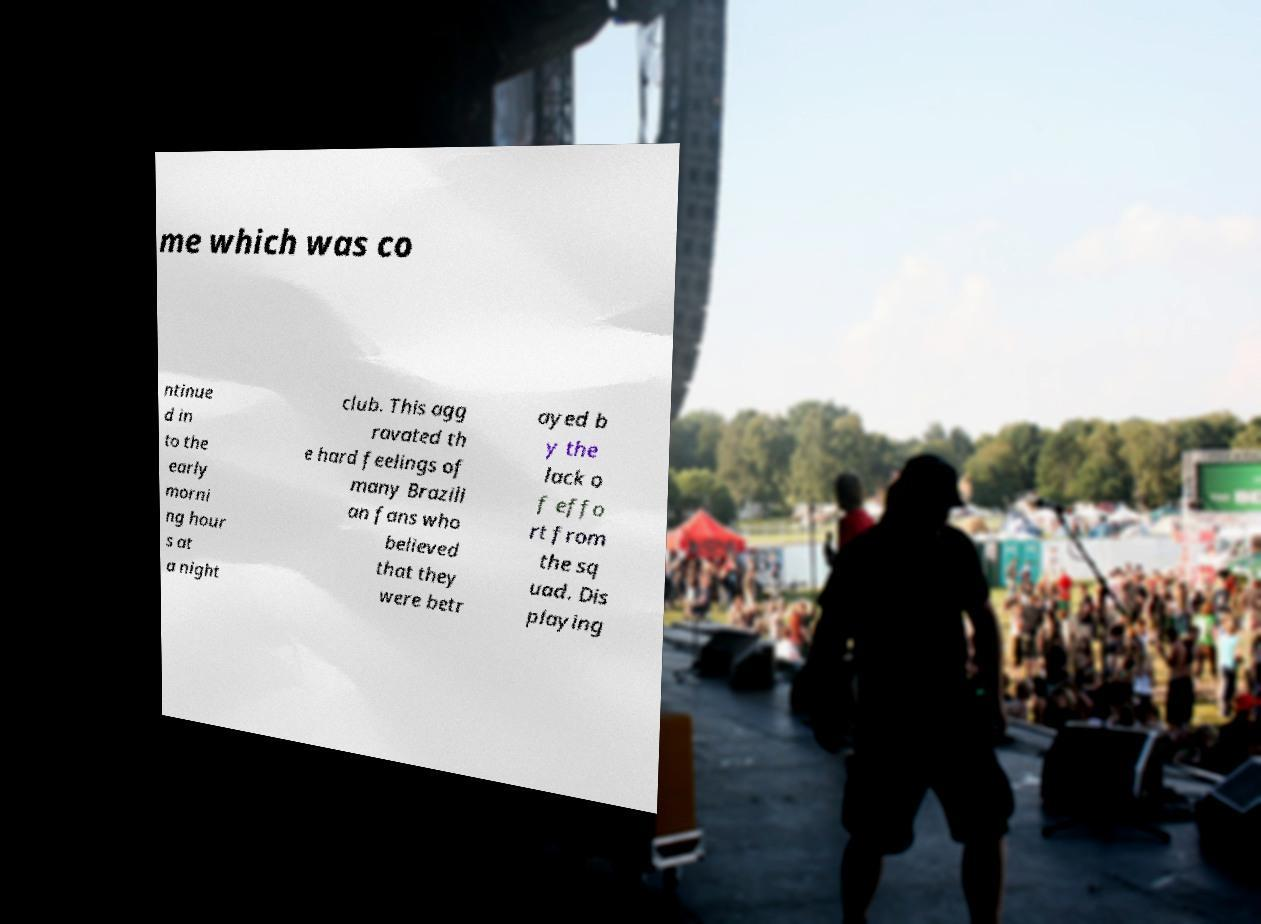Can you read and provide the text displayed in the image?This photo seems to have some interesting text. Can you extract and type it out for me? me which was co ntinue d in to the early morni ng hour s at a night club. This agg ravated th e hard feelings of many Brazili an fans who believed that they were betr ayed b y the lack o f effo rt from the sq uad. Dis playing 